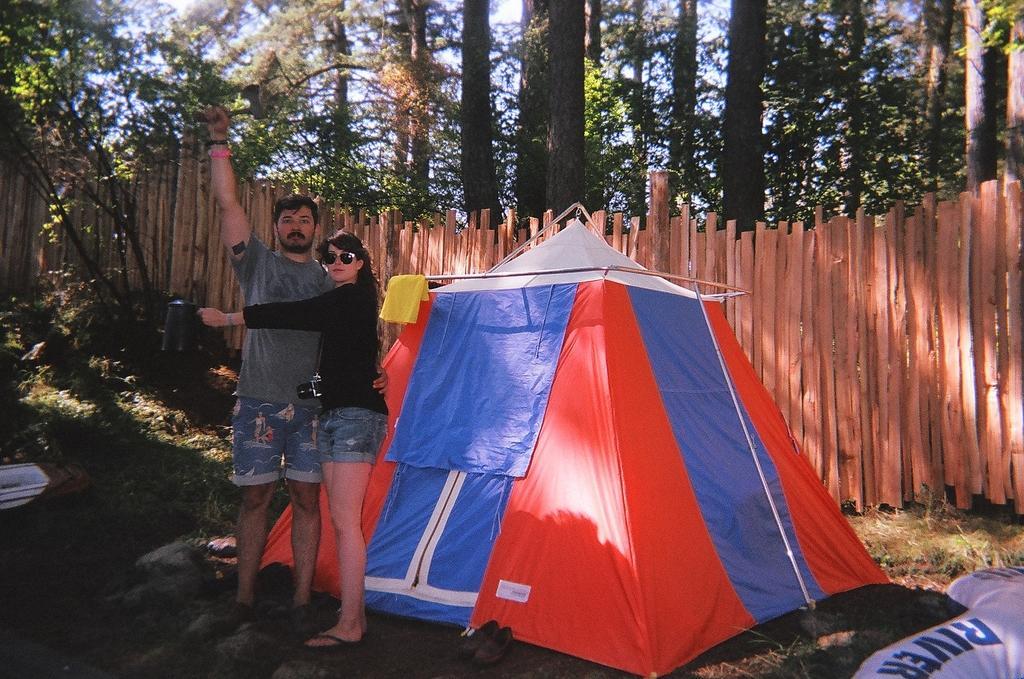How would you summarize this image in a sentence or two? In this image there is a tent in the center and there are persons standing in front of the tent. In the background there is a wooden fence and there are trees and there's grass on the ground. 